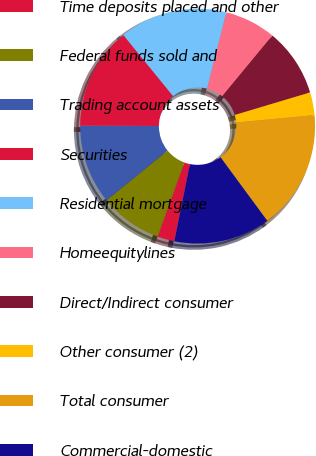Convert chart. <chart><loc_0><loc_0><loc_500><loc_500><pie_chart><fcel>Time deposits placed and other<fcel>Federal funds sold and<fcel>Trading account assets<fcel>Securities<fcel>Residential mortgage<fcel>Homeequitylines<fcel>Direct/Indirect consumer<fcel>Other consumer (2)<fcel>Total consumer<fcel>Commercial-domestic<nl><fcel>2.36%<fcel>8.6%<fcel>10.94%<fcel>14.06%<fcel>14.84%<fcel>7.04%<fcel>9.38%<fcel>3.14%<fcel>16.4%<fcel>13.28%<nl></chart> 